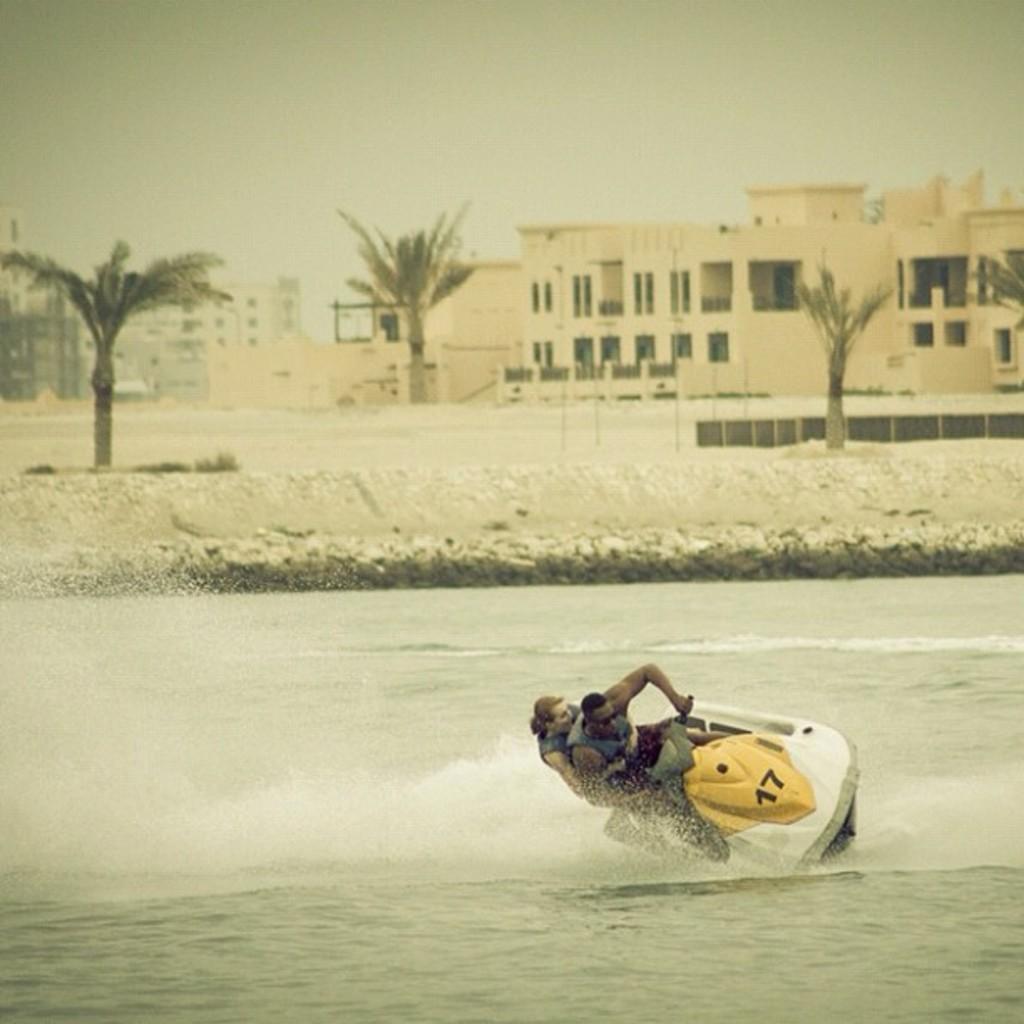How would you summarize this image in a sentence or two? In this image there are two persons riding on boat visible in the water, in middle there are buildings, trees visible, at the top there is the sky. 